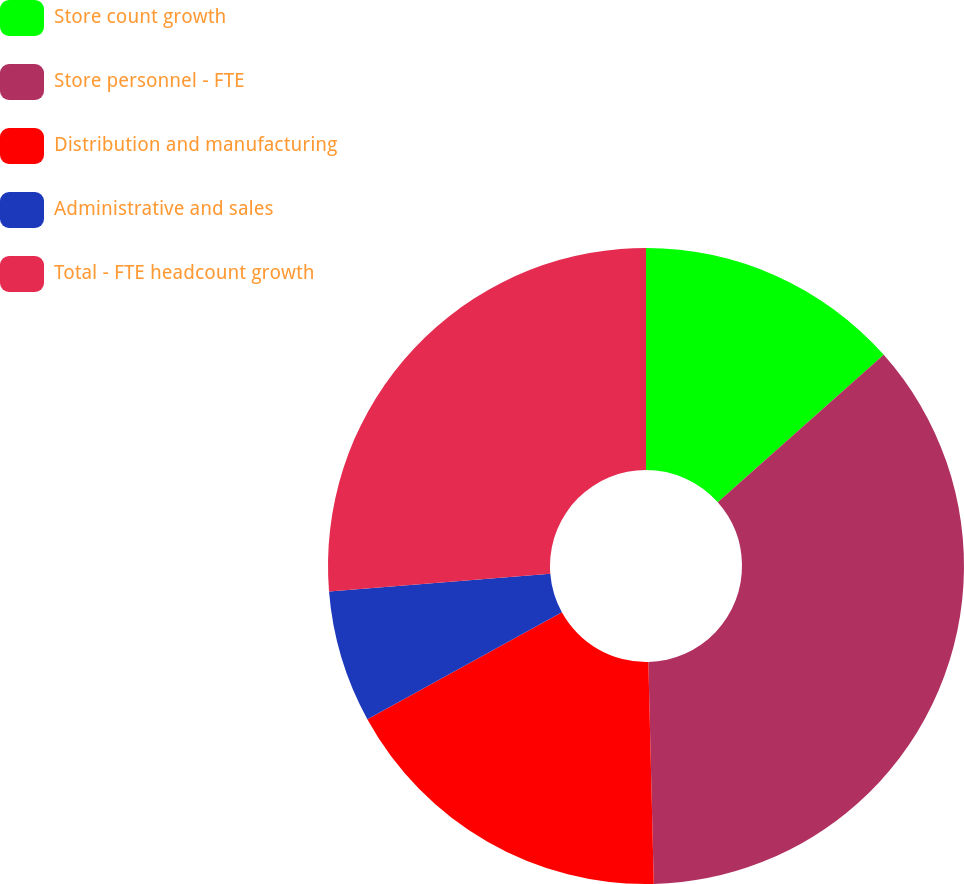<chart> <loc_0><loc_0><loc_500><loc_500><pie_chart><fcel>Store count growth<fcel>Store personnel - FTE<fcel>Distribution and manufacturing<fcel>Administrative and sales<fcel>Total - FTE headcount growth<nl><fcel>13.44%<fcel>36.17%<fcel>17.39%<fcel>6.72%<fcel>26.28%<nl></chart> 